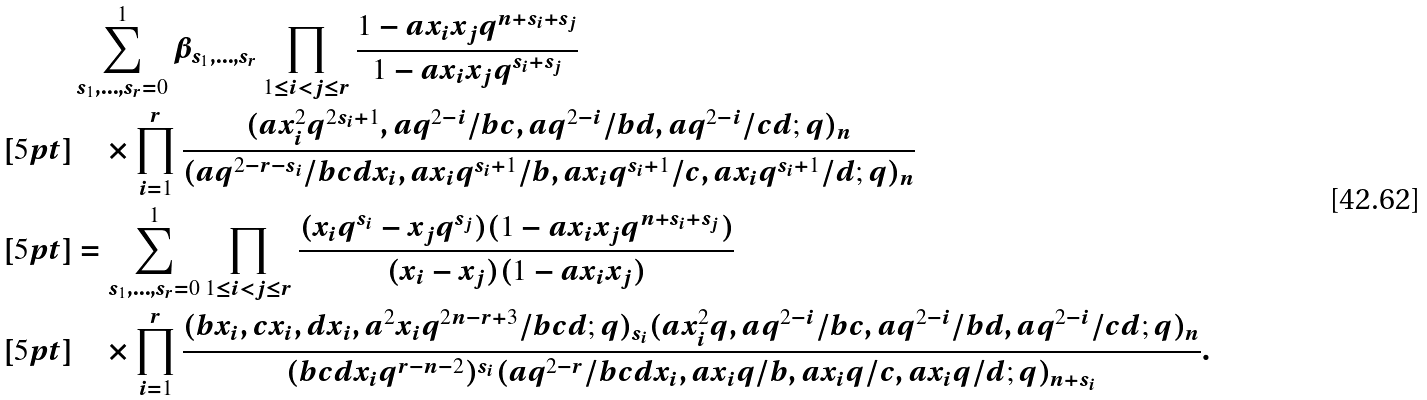<formula> <loc_0><loc_0><loc_500><loc_500>& \sum _ { s _ { 1 } , \dots , s _ { r } = 0 } ^ { 1 } \beta _ { s _ { 1 } , \dots , s _ { r } } \prod _ { 1 \leq i < j \leq r } \frac { 1 - a x _ { i } x _ { j } q ^ { n + s _ { i } + s _ { j } } } { 1 - a x _ { i } x _ { j } q ^ { s _ { i } + s _ { j } } } \\ [ 5 p t ] & \quad \times \prod _ { i = 1 } ^ { r } \frac { ( a x _ { i } ^ { 2 } q ^ { 2 s _ { i } + 1 } , a q ^ { 2 - i } / b c , a q ^ { 2 - i } / b d , a q ^ { 2 - i } / c d ; q ) _ { n } } { ( a q ^ { 2 - r - s _ { i } } / b c d x _ { i } , a x _ { i } q ^ { s _ { i } + 1 } / b , a x _ { i } q ^ { s _ { i } + 1 } / c , a x _ { i } q ^ { s _ { i } + 1 } / d ; q ) _ { n } } \\ [ 5 p t ] & = \sum _ { s _ { 1 } , \dots , s _ { r } = 0 } ^ { 1 } \prod _ { 1 \leq i < j \leq r } \frac { ( x _ { i } q ^ { s _ { i } } - x _ { j } q ^ { s _ { j } } ) ( 1 - a x _ { i } x _ { j } q ^ { n + s _ { i } + s _ { j } } ) } { ( x _ { i } - x _ { j } ) ( 1 - a x _ { i } x _ { j } ) } \\ [ 5 p t ] & \quad \times \prod _ { i = 1 } ^ { r } \frac { ( b x _ { i } , c x _ { i } , d x _ { i } , a ^ { 2 } x _ { i } q ^ { 2 n - r + 3 } / b c d ; q ) _ { s _ { i } } ( a x _ { i } ^ { 2 } q , a q ^ { 2 - i } / b c , a q ^ { 2 - i } / b d , a q ^ { 2 - i } / c d ; q ) _ { n } } { ( b c d x _ { i } q ^ { r - n - 2 } ) ^ { s _ { i } } ( a q ^ { 2 - r } / b c d x _ { i } , a x _ { i } q / b , a x _ { i } q / c , a x _ { i } q / d ; q ) _ { n + s _ { i } } } .</formula> 